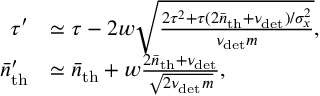<formula> <loc_0><loc_0><loc_500><loc_500>\begin{array} { r l } { \tau ^ { \prime } } & { \simeq \tau - 2 w \sqrt { \frac { 2 \tau ^ { 2 } + \tau ( 2 \bar { n } _ { t h } + \nu _ { d e t } ) / \sigma _ { x } ^ { 2 } } { \nu _ { d e t } m } } , } \\ { \bar { n } _ { t h } ^ { \prime } } & { \simeq \bar { n } _ { t h } + w \frac { 2 \bar { n } _ { t h } + \nu _ { d e t } } { \sqrt { 2 \nu _ { d e t } m } } , } \end{array}</formula> 